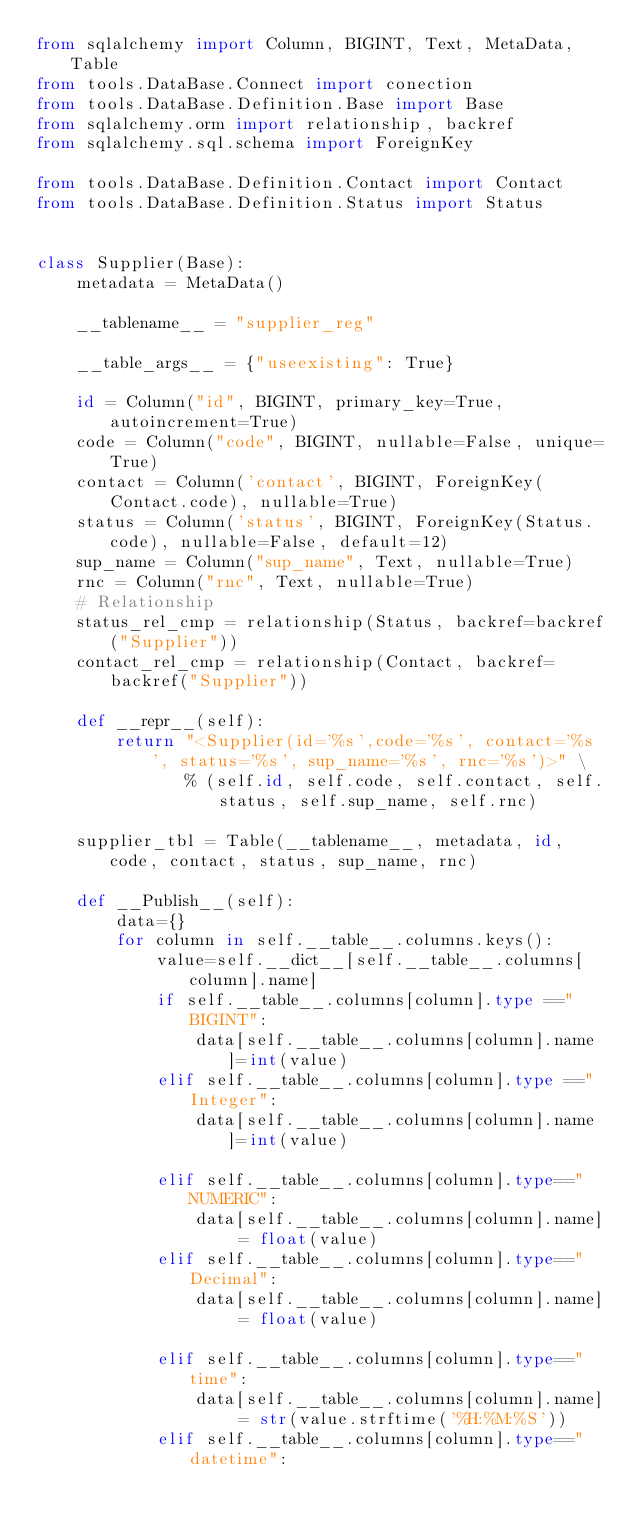Convert code to text. <code><loc_0><loc_0><loc_500><loc_500><_Python_>from sqlalchemy import Column, BIGINT, Text, MetaData, Table
from tools.DataBase.Connect import conection
from tools.DataBase.Definition.Base import Base
from sqlalchemy.orm import relationship, backref
from sqlalchemy.sql.schema import ForeignKey

from tools.DataBase.Definition.Contact import Contact
from tools.DataBase.Definition.Status import Status


class Supplier(Base):
    metadata = MetaData()

    __tablename__ = "supplier_reg"

    __table_args__ = {"useexisting": True}

    id = Column("id", BIGINT, primary_key=True, autoincrement=True)
    code = Column("code", BIGINT, nullable=False, unique=True)
    contact = Column('contact', BIGINT, ForeignKey(Contact.code), nullable=True)
    status = Column('status', BIGINT, ForeignKey(Status.code), nullable=False, default=12)
    sup_name = Column("sup_name", Text, nullable=True)
    rnc = Column("rnc", Text, nullable=True)
    # Relationship
    status_rel_cmp = relationship(Status, backref=backref("Supplier"))
    contact_rel_cmp = relationship(Contact, backref=backref("Supplier"))

    def __repr__(self):
        return "<Supplier(id='%s',code='%s', contact='%s', status='%s', sup_name='%s', rnc='%s')>" \
               % (self.id, self.code, self.contact, self.status, self.sup_name, self.rnc)

    supplier_tbl = Table(__tablename__, metadata, id, code, contact, status, sup_name, rnc)

    def __Publish__(self):
        data={}
        for column in self.__table__.columns.keys():
            value=self.__dict__[self.__table__.columns[column].name]
            if self.__table__.columns[column].type =="BIGINT":
                data[self.__table__.columns[column].name]=int(value)
            elif self.__table__.columns[column].type =="Integer":
                data[self.__table__.columns[column].name]=int(value)

            elif self.__table__.columns[column].type=="NUMERIC":
                data[self.__table__.columns[column].name] = float(value)
            elif self.__table__.columns[column].type=="Decimal":
                data[self.__table__.columns[column].name] = float(value)

            elif self.__table__.columns[column].type=="time":
                data[self.__table__.columns[column].name] = str(value.strftime('%H:%M:%S'))
            elif self.__table__.columns[column].type=="datetime":</code> 